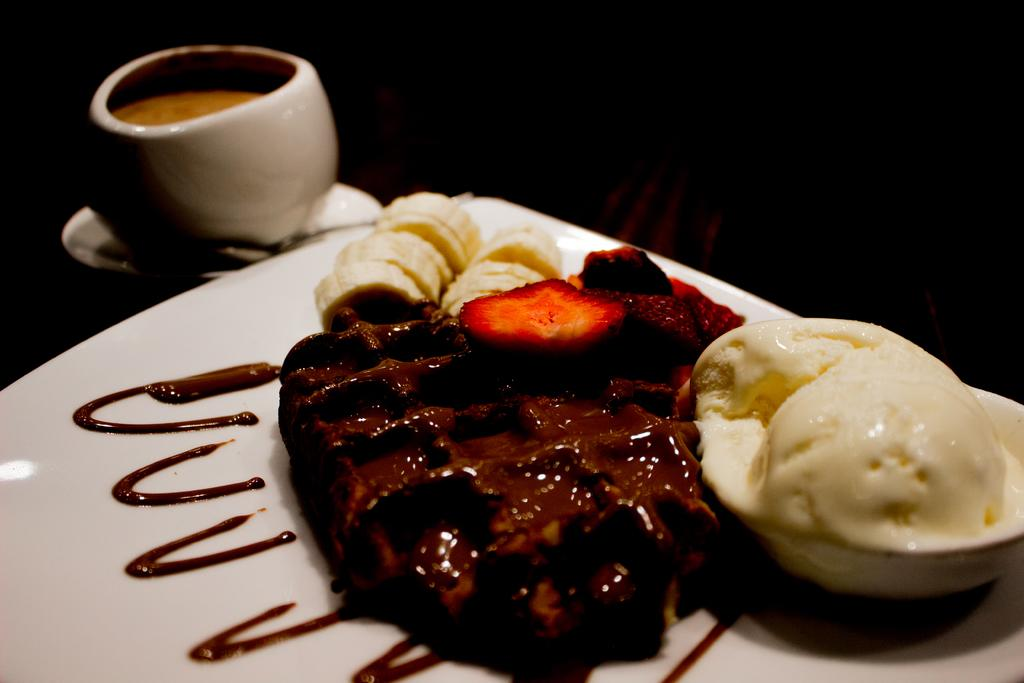What is on the plate that is visible in the image? There is a food item on the plate in the image. What is in the bowl that is visible in the image? There is an item in the bowl in the image. How is the bowl positioned in relation to the saucer? The bowl is on a saucer in the image. What can be observed about the lighting in the image? The background of the image is dark. What type of skin is visible on the person in the image? There is no person visible in the image, so it is not possible to determine the type of skin present. 